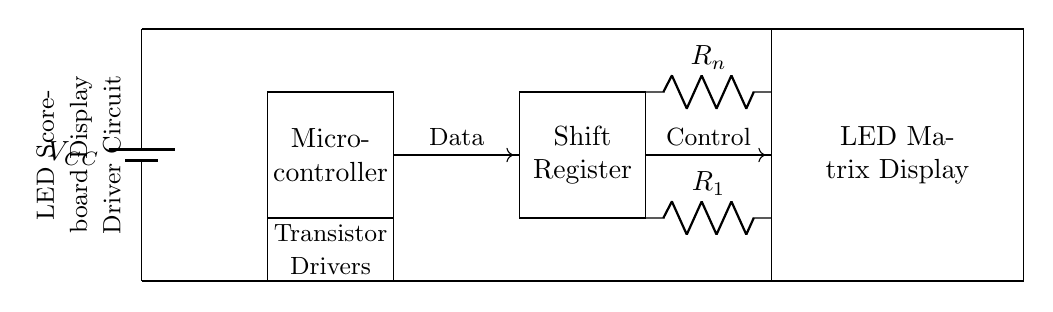What type of microcontroller is shown in the circuit? The microcontroller is represented as a rectangular block labeled "Micro-controller." This indicates that a typical microcontroller is utilized, though the specific type is not defined in the diagram.
Answer: Micro-controller What do the resistors in the circuit represent? The resistors are labeled as R1 and Rn and are placed in series with the LED matrix display, indicating their role as current limiting resistors to protect the LEDs from excessive current.
Answer: Current limiting resistors How many transistors are used in this circuit? Two transistor symbols (a PNP and an NPN) are visible in the diagram, both located on the left side connected to the microcontroller, indicating the circuit uses two transistors.
Answer: Two What type of display is being driven by this circuit? The circuit features a rectangular block labeled "LED Matrix Display," indicating that the device being driven is specifically an LED matrix display which is commonly used in scoreboards.
Answer: LED Matrix Display What is the purpose of the shift register in this circuit? The shift register, represented by another rectangular block, is used to store and shift the data (signals) needed to control the LEDs, allowing for the sequential lighting of the LED matrix in the scoreboard display.
Answer: Store and shift data What is the power supply voltage denoted in the circuit? The power supply is labeled as "VCC," which typically refers to a positive voltage in circuit designs; however, the exact numerical value is not specified in this circuit diagram.
Answer: VCC 